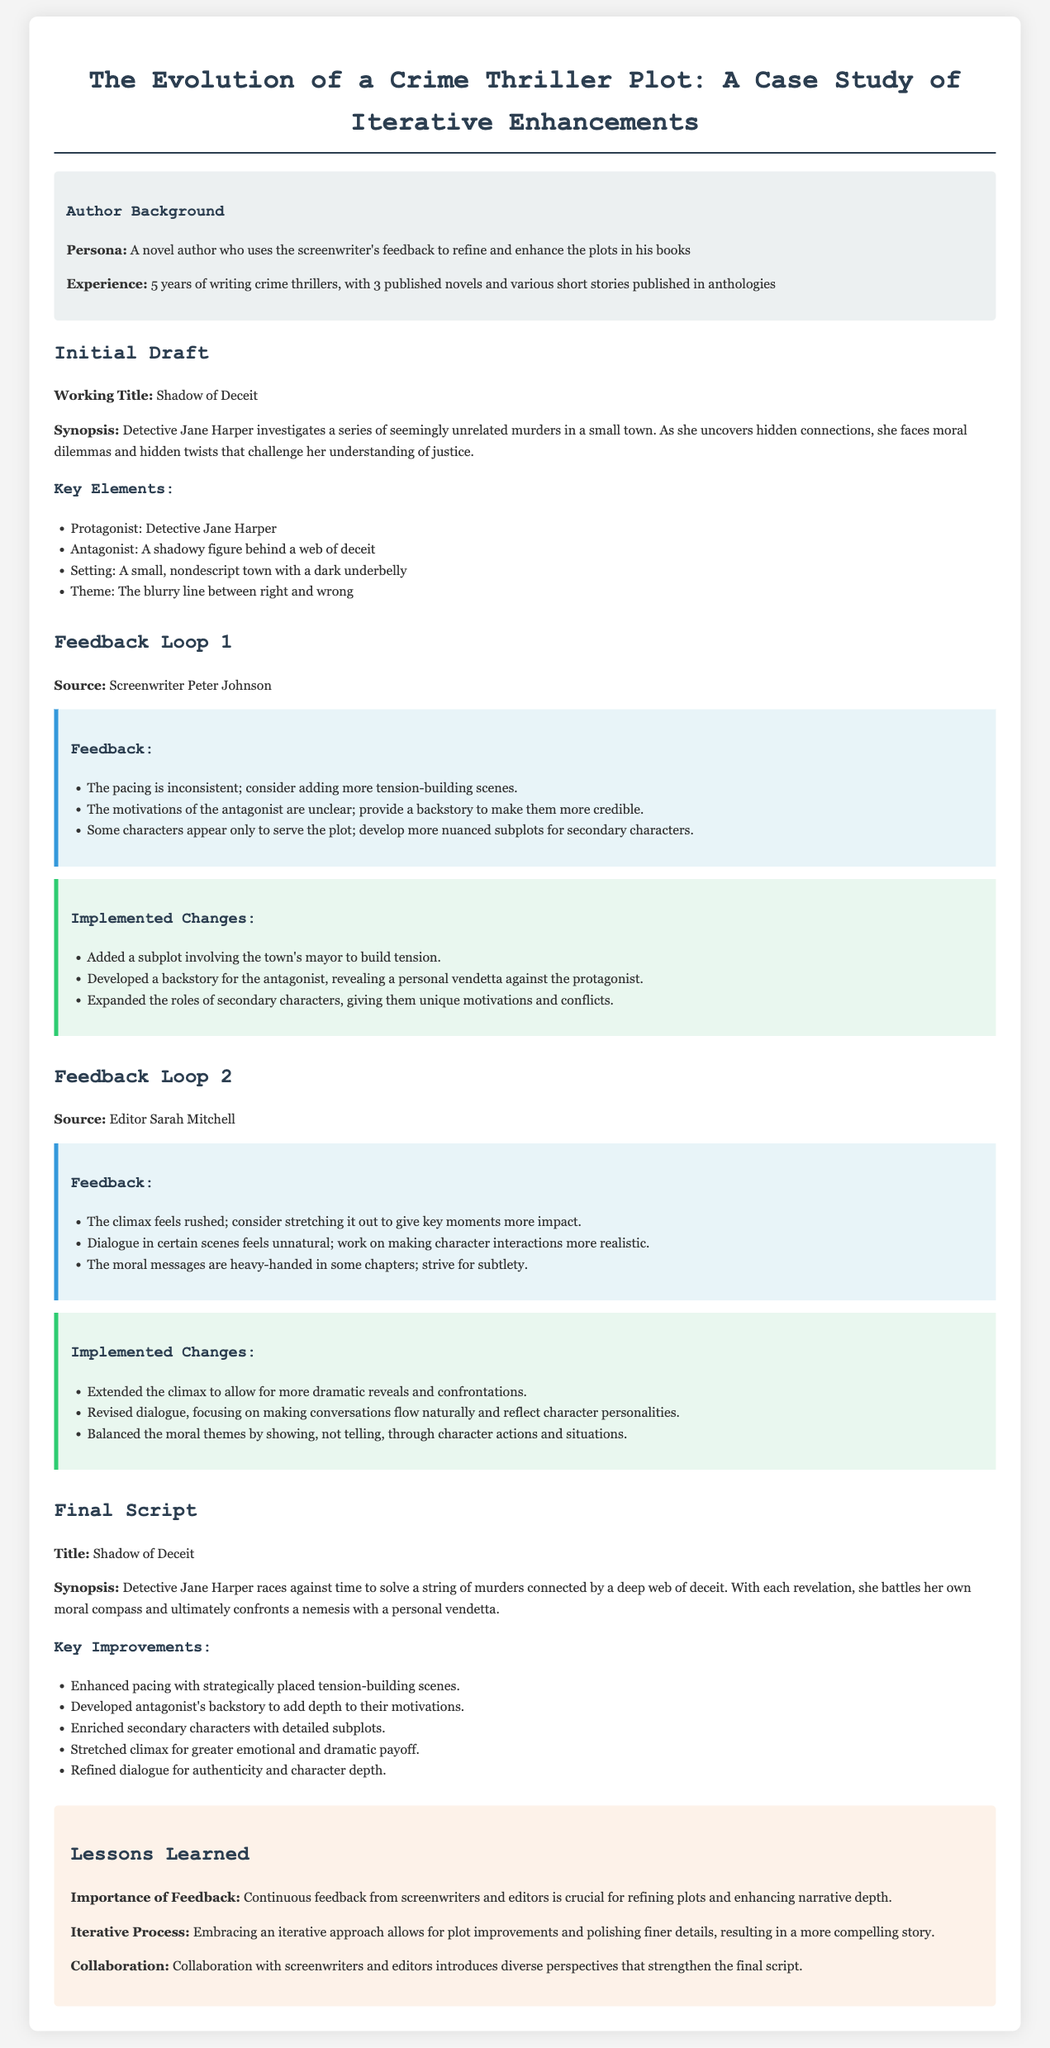what is the working title of the initial draft? The working title is the title of the draft as mentioned in the document.
Answer: Shadow of Deceit who provided the first round of feedback? The first round of feedback is attributed to the screenwriter named in the document.
Answer: Peter Johnson what is the protagonist's name? The protagonist's name is specified in the key elements of the plot.
Answer: Detective Jane Harper how many published novels does the author have? The number of published novels is stated in the author background section.
Answer: 3 what aspect of the climax was changed according to the editor's feedback? This question involves understanding how feedback impacted the climax.
Answer: Stretched out what major theme is explored in the plot? The theme is clearly mentioned in the key elements section of the document.
Answer: The blurry line between right and wrong how many key improvements are listed in the final script section? The total number of improvements is provided in the final script section.
Answer: 5 what lesson emphasizes the importance of collaboration? The lesson learned mentions collaboration among contributors.
Answer: Collaboration who provided the second round of feedback? This question seeks to clarify who gave the subsequent feedback.
Answer: Sarah Mitchell 